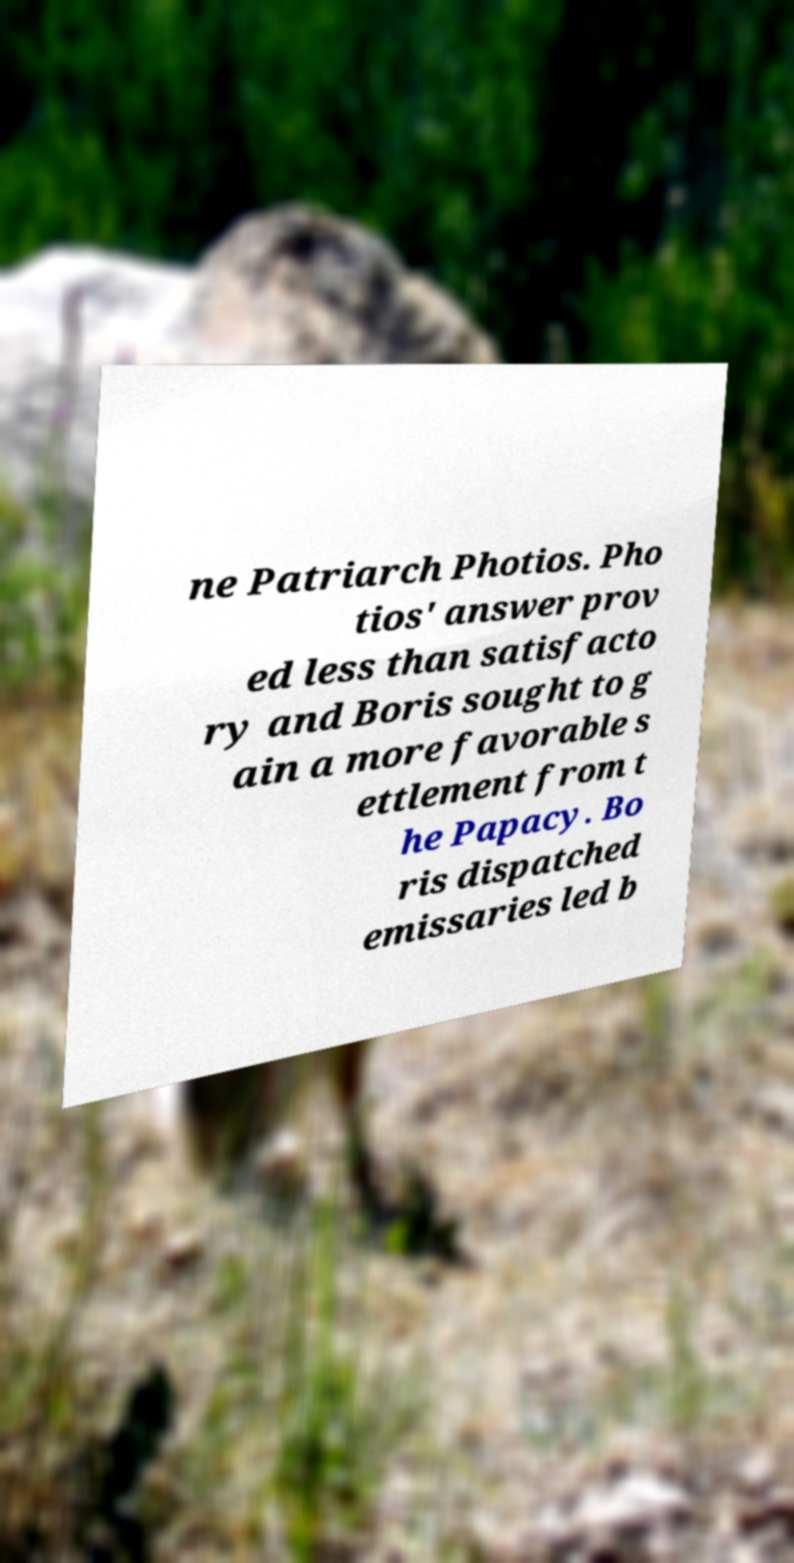There's text embedded in this image that I need extracted. Can you transcribe it verbatim? ne Patriarch Photios. Pho tios' answer prov ed less than satisfacto ry and Boris sought to g ain a more favorable s ettlement from t he Papacy. Bo ris dispatched emissaries led b 